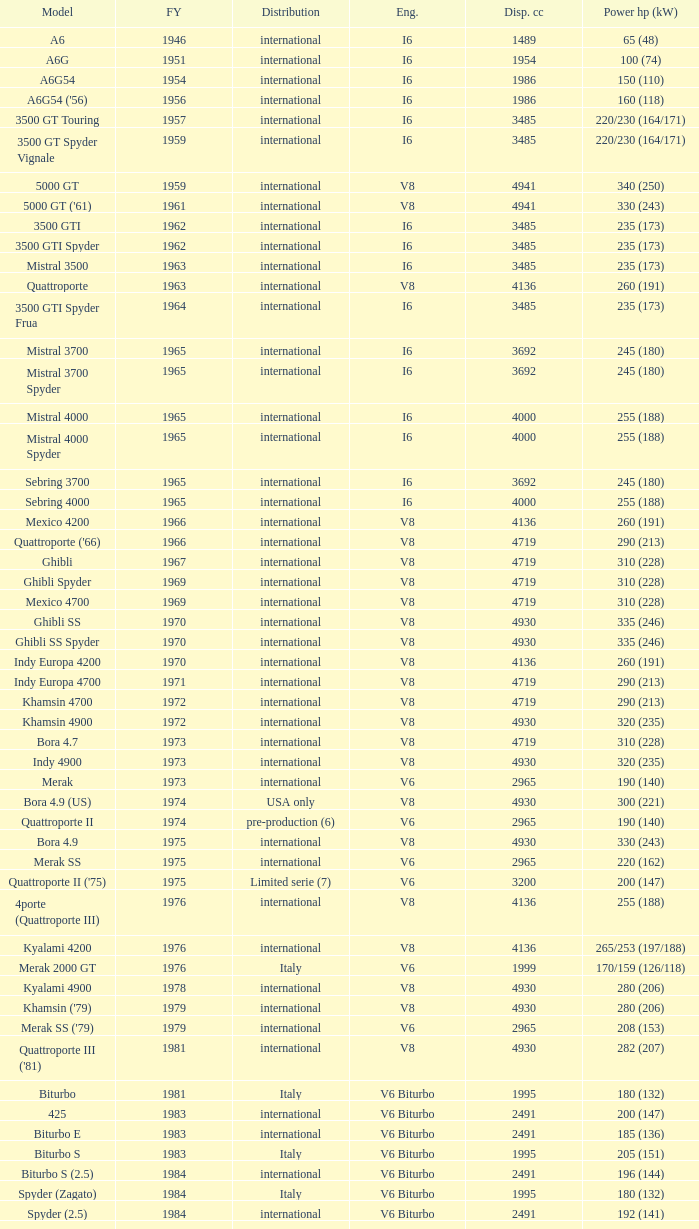Could you parse the entire table? {'header': ['Model', 'FY', 'Distribution', 'Eng.', 'Disp. cc', 'Power hp (kW)'], 'rows': [['A6', '1946', 'international', 'I6', '1489', '65 (48)'], ['A6G', '1951', 'international', 'I6', '1954', '100 (74)'], ['A6G54', '1954', 'international', 'I6', '1986', '150 (110)'], ["A6G54 ('56)", '1956', 'international', 'I6', '1986', '160 (118)'], ['3500 GT Touring', '1957', 'international', 'I6', '3485', '220/230 (164/171)'], ['3500 GT Spyder Vignale', '1959', 'international', 'I6', '3485', '220/230 (164/171)'], ['5000 GT', '1959', 'international', 'V8', '4941', '340 (250)'], ["5000 GT ('61)", '1961', 'international', 'V8', '4941', '330 (243)'], ['3500 GTI', '1962', 'international', 'I6', '3485', '235 (173)'], ['3500 GTI Spyder', '1962', 'international', 'I6', '3485', '235 (173)'], ['Mistral 3500', '1963', 'international', 'I6', '3485', '235 (173)'], ['Quattroporte', '1963', 'international', 'V8', '4136', '260 (191)'], ['3500 GTI Spyder Frua', '1964', 'international', 'I6', '3485', '235 (173)'], ['Mistral 3700', '1965', 'international', 'I6', '3692', '245 (180)'], ['Mistral 3700 Spyder', '1965', 'international', 'I6', '3692', '245 (180)'], ['Mistral 4000', '1965', 'international', 'I6', '4000', '255 (188)'], ['Mistral 4000 Spyder', '1965', 'international', 'I6', '4000', '255 (188)'], ['Sebring 3700', '1965', 'international', 'I6', '3692', '245 (180)'], ['Sebring 4000', '1965', 'international', 'I6', '4000', '255 (188)'], ['Mexico 4200', '1966', 'international', 'V8', '4136', '260 (191)'], ["Quattroporte ('66)", '1966', 'international', 'V8', '4719', '290 (213)'], ['Ghibli', '1967', 'international', 'V8', '4719', '310 (228)'], ['Ghibli Spyder', '1969', 'international', 'V8', '4719', '310 (228)'], ['Mexico 4700', '1969', 'international', 'V8', '4719', '310 (228)'], ['Ghibli SS', '1970', 'international', 'V8', '4930', '335 (246)'], ['Ghibli SS Spyder', '1970', 'international', 'V8', '4930', '335 (246)'], ['Indy Europa 4200', '1970', 'international', 'V8', '4136', '260 (191)'], ['Indy Europa 4700', '1971', 'international', 'V8', '4719', '290 (213)'], ['Khamsin 4700', '1972', 'international', 'V8', '4719', '290 (213)'], ['Khamsin 4900', '1972', 'international', 'V8', '4930', '320 (235)'], ['Bora 4.7', '1973', 'international', 'V8', '4719', '310 (228)'], ['Indy 4900', '1973', 'international', 'V8', '4930', '320 (235)'], ['Merak', '1973', 'international', 'V6', '2965', '190 (140)'], ['Bora 4.9 (US)', '1974', 'USA only', 'V8', '4930', '300 (221)'], ['Quattroporte II', '1974', 'pre-production (6)', 'V6', '2965', '190 (140)'], ['Bora 4.9', '1975', 'international', 'V8', '4930', '330 (243)'], ['Merak SS', '1975', 'international', 'V6', '2965', '220 (162)'], ["Quattroporte II ('75)", '1975', 'Limited serie (7)', 'V6', '3200', '200 (147)'], ['4porte (Quattroporte III)', '1976', 'international', 'V8', '4136', '255 (188)'], ['Kyalami 4200', '1976', 'international', 'V8', '4136', '265/253 (197/188)'], ['Merak 2000 GT', '1976', 'Italy', 'V6', '1999', '170/159 (126/118)'], ['Kyalami 4900', '1978', 'international', 'V8', '4930', '280 (206)'], ["Khamsin ('79)", '1979', 'international', 'V8', '4930', '280 (206)'], ["Merak SS ('79)", '1979', 'international', 'V6', '2965', '208 (153)'], ["Quattroporte III ('81)", '1981', 'international', 'V8', '4930', '282 (207)'], ['Biturbo', '1981', 'Italy', 'V6 Biturbo', '1995', '180 (132)'], ['425', '1983', 'international', 'V6 Biturbo', '2491', '200 (147)'], ['Biturbo E', '1983', 'international', 'V6 Biturbo', '2491', '185 (136)'], ['Biturbo S', '1983', 'Italy', 'V6 Biturbo', '1995', '205 (151)'], ['Biturbo S (2.5)', '1984', 'international', 'V6 Biturbo', '2491', '196 (144)'], ['Spyder (Zagato)', '1984', 'Italy', 'V6 Biturbo', '1995', '180 (132)'], ['Spyder (2.5)', '1984', 'international', 'V6 Biturbo', '2491', '192 (141)'], ['420', '1985', 'Italy', 'V6 Biturbo', '1995', '180 (132)'], ['Biturbo (II)', '1985', 'Italy', 'V6 Biturbo', '1995', '180 (132)'], ['Biturbo E (II 2.5)', '1985', 'international', 'V6 Biturbo', '2491', '185 (136)'], ['Biturbo S (II)', '1985', 'Italy', 'V6 Biturbo', '1995', '210 (154)'], ['228 (228i)', '1986', 'international', 'V6 Biturbo', '2790', '250 (184)'], ['228 (228i) Kat', '1986', 'international', 'V6 Biturbo', '2790', '225 (165)'], ['420i', '1986', 'Italy', 'V6 Biturbo', '1995', '190 (140)'], ['420 S', '1986', 'Italy', 'V6 Biturbo', '1995', '210 (154)'], ['Biturbo i', '1986', 'Italy', 'V6 Biturbo', '1995', '185 (136)'], ['Quattroporte Royale (III)', '1986', 'international', 'V8', '4930', '300 (221)'], ['Spyder i', '1986', 'international', 'V6 Biturbo', '1996', '185 (136)'], ['430', '1987', 'international', 'V6 Biturbo', '2790', '225 (165)'], ['425i', '1987', 'international', 'V6 Biturbo', '2491', '188 (138)'], ['Biturbo Si', '1987', 'Italy', 'V6 Biturbo', '1995', '220 (162)'], ['Biturbo Si (2.5)', '1987', 'international', 'V6 Biturbo', '2491', '188 (138)'], ["Spyder i ('87)", '1987', 'international', 'V6 Biturbo', '1996', '195 (143)'], ['222', '1988', 'Italy', 'V6 Biturbo', '1996', '220 (162)'], ['422', '1988', 'Italy', 'V6 Biturbo', '1996', '220 (162)'], ['2.24V', '1988', 'Italy (probably)', 'V6 Biturbo', '1996', '245 (180)'], ['222 4v', '1988', 'international', 'V6 Biturbo', '2790', '279 (205)'], ['222 E', '1988', 'international', 'V6 Biturbo', '2790', '225 (165)'], ['Karif', '1988', 'international', 'V6 Biturbo', '2790', '285 (210)'], ['Karif (kat)', '1988', 'international', 'V6 Biturbo', '2790', '248 (182)'], ['Karif (kat II)', '1988', 'international', 'V6 Biturbo', '2790', '225 (165)'], ['Spyder i (2.5)', '1988', 'international', 'V6 Biturbo', '2491', '188 (138)'], ['Spyder i (2.8)', '1989', 'international', 'V6 Biturbo', '2790', '250 (184)'], ['Spyder i (2.8, kat)', '1989', 'international', 'V6 Biturbo', '2790', '225 (165)'], ["Spyder i ('90)", '1989', 'Italy', 'V6 Biturbo', '1996', '220 (162)'], ['222 SE', '1990', 'international', 'V6 Biturbo', '2790', '250 (184)'], ['222 SE (kat)', '1990', 'international', 'V6 Biturbo', '2790', '225 (165)'], ['4.18v', '1990', 'Italy', 'V6 Biturbo', '1995', '220 (162)'], ['4.24v', '1990', 'Italy (probably)', 'V6 Biturbo', '1996', '245 (180)'], ['Shamal', '1990', 'international', 'V8 Biturbo', '3217', '326 (240)'], ['2.24v II', '1991', 'Italy', 'V6 Biturbo', '1996', '245 (180)'], ['2.24v II (kat)', '1991', 'international (probably)', 'V6 Biturbo', '1996', '240 (176)'], ['222 SR', '1991', 'international', 'V6 Biturbo', '2790', '225 (165)'], ['4.24v II (kat)', '1991', 'Italy (probably)', 'V6 Biturbo', '1996', '240 (176)'], ['430 4v', '1991', 'international', 'V6 Biturbo', '2790', '279 (205)'], ['Racing', '1991', 'Italy', 'V6 Biturbo', '1996', '283 (208)'], ['Spyder III', '1991', 'Italy', 'V6 Biturbo', '1996', '245 (180)'], ['Spyder III (2.8, kat)', '1991', 'international', 'V6 Biturbo', '2790', '225 (165)'], ['Spyder III (kat)', '1991', 'Italy', 'V6 Biturbo', '1996', '240 (176)'], ['Barchetta Stradale', '1992', 'Prototype', 'V6 Biturbo', '1996', '306 (225)'], ['Barchetta Stradale 2.8', '1992', 'Single, Conversion', 'V6 Biturbo', '2790', '284 (209)'], ['Ghibli II (2.0)', '1992', 'Italy', 'V6 Biturbo', '1996', '306 (225)'], ['Ghibli II (2.8)', '1993', 'international', 'V6 Biturbo', '2790', '284 (209)'], ['Quattroporte (2.0)', '1994', 'Italy', 'V6 Biturbo', '1996', '287 (211)'], ['Quattroporte (2.8)', '1994', 'international', 'V6 Biturbo', '2790', '284 (209)'], ['Ghibli Cup', '1995', 'international', 'V6 Biturbo', '1996', '330 (243)'], ['Quattroporte Ottocilindri', '1995', 'international', 'V8 Biturbo', '3217', '335 (246)'], ['Ghibli Primatist', '1996', 'international', 'V6 Biturbo', '1996', '306 (225)'], ['3200 GT', '1998', 'international', 'V8 Biturbo', '3217', '370 (272)'], ['Quattroporte V6 Evoluzione', '1998', 'international', 'V6 Biturbo', '2790', '284 (209)'], ['Quattroporte V8 Evoluzione', '1998', 'international', 'V8 Biturbo', '3217', '335 (246)'], ['3200 GTA', '2000', 'international', 'V8 Biturbo', '3217', '368 (271)'], ['Spyder GT', '2001', 'international', 'V8', '4244', '390 (287)'], ['Spyder CC', '2001', 'international', 'V8', '4244', '390 (287)'], ['Coupé GT', '2001', 'international', 'V8', '4244', '390 (287)'], ['Coupé CC', '2001', 'international', 'V8', '4244', '390 (287)'], ['Gran Sport', '2002', 'international', 'V8', '4244', '400 (294)'], ['Quattroporte V', '2004', 'international', 'V8', '4244', '400 (294)'], ['MC12 (aka MCC)', '2004', 'Limited', 'V12', '5998', '630 (463)'], ['GranTurismo', '2008', 'international', 'V8', '4244', '405'], ['GranCabrio', '2010', 'international', 'V8', '4691', '433']]} What is the lowest First Year, when Model is "Quattroporte (2.8)"? 1994.0. 